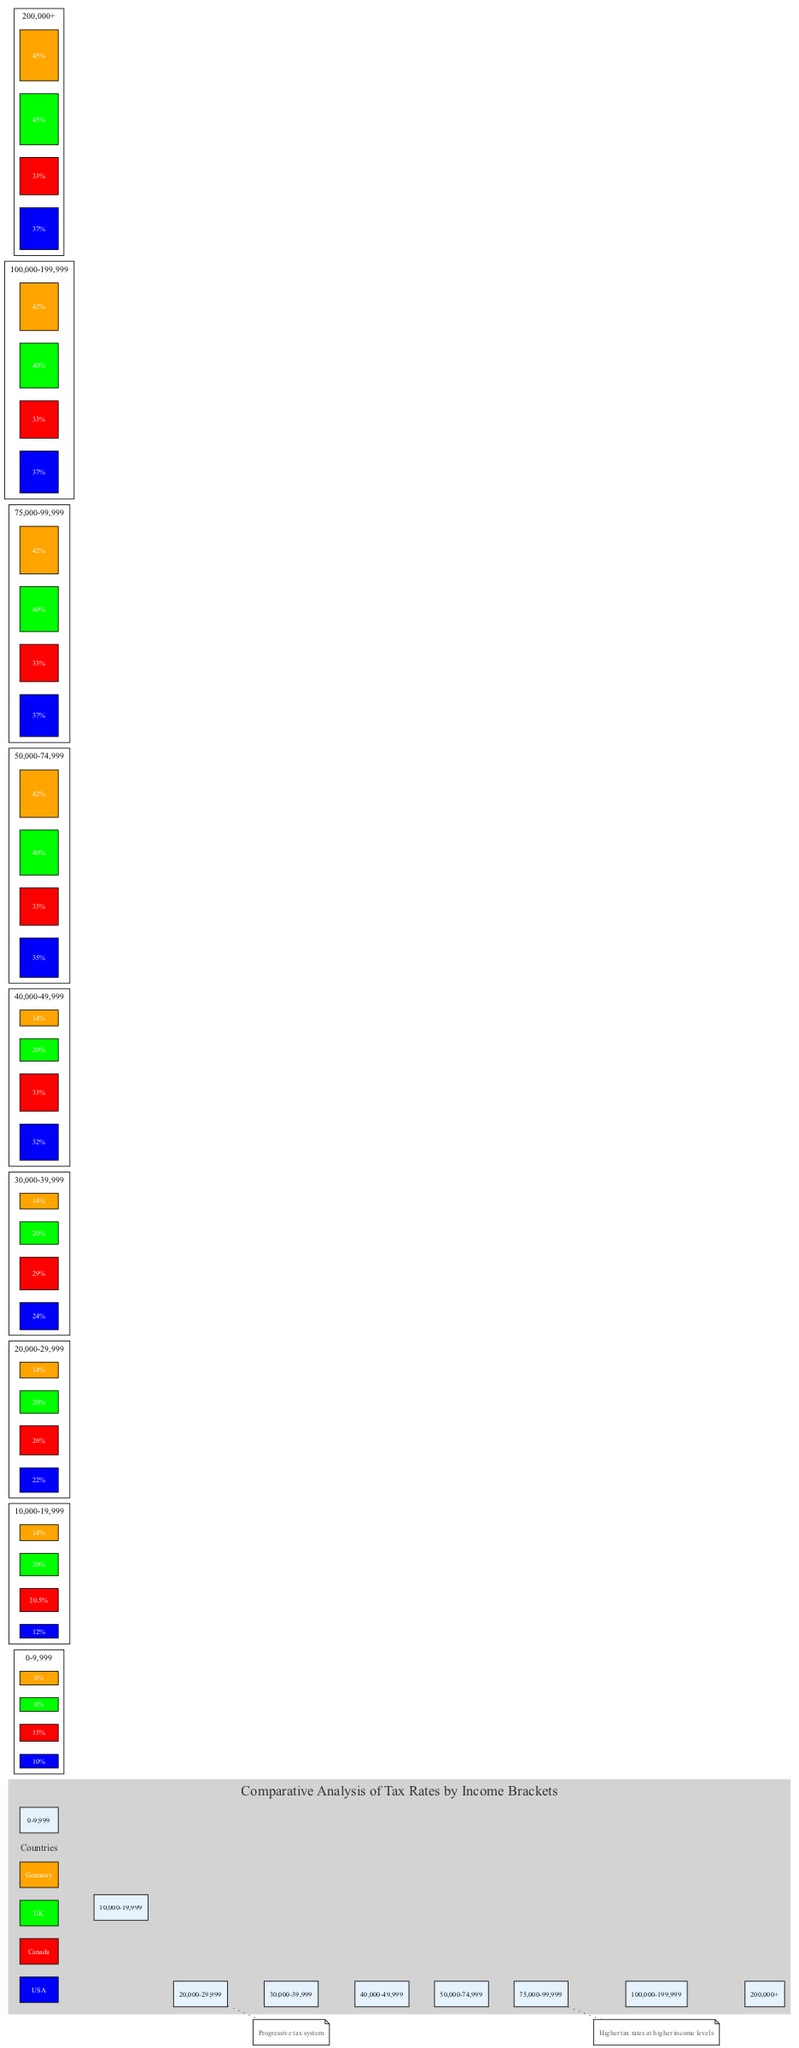What is the tax rate for the income bracket 30,000-39,999 in the USA? The USA's tax rate for the 30,000-39,999 income bracket is represented by the bar at this bracket on the chart, which indicates a tax rate of 24%.
Answer: 24% Which country has the highest tax rate for the income bracket 200,000+? By examining the highest bracket for each country in the diagram, it can be seen that the UK has the highest tax rate of 45% for the income bracket 200,000+.
Answer: UK What is the tax rate for the income bracket 50,000-74,999 in Canada? The tax rate for the income bracket 50,000-74,999 in Canada can be found by looking at the corresponding bar in the diagram, which shows a rate of 33%.
Answer: 33% What is the lowest tax rate in Germany across all income brackets? To determine the lowest tax rate in Germany, we look across all the corresponding bars from each income bracket; the lowest tax rate is 0% found in the first two brackets (0-9,999 and 10,000-19,999).
Answer: 0% Which country has a flat tax rate (same rate across all income brackets)? By observing the bars for each country, it is clear that Canada does not have a flat tax rate, as its rates change across brackets, while Germany shows a near-flat rate of 42% from 50,000-99,999, and 45% for the highest bracket, making it the closest to a flat tax structure among the countries shown.
Answer: Germany What type of tax system is indicated for income brackets with higher rates? The annotations in the diagram mention a "Progressive tax system", indicating that as income levels rise, the tax rate increases for most countries, supporting the concept of progressive taxation.
Answer: Progressive tax system In which income bracket does the tax rate start to exceed 30% for the USA? Observing the tax rates for the USA, the tax rate exceeds 30% starting from the income bracket 40,000-49,999 where it is 32%.
Answer: 40,000-49,999 What is the color representing the UK in the diagram? The legend indicates that the UK is represented by the color green in the diagram, which can be correlated with the respective bars.
Answer: Green Which income bracket has the same tax rate for Canada and Germany? By cross-referencing the tax rates within the respective bars, it is evident that for the income bracket 50,000-74,999, both Canada and Germany have a tax rate of 33%.
Answer: 50,000-74,999 